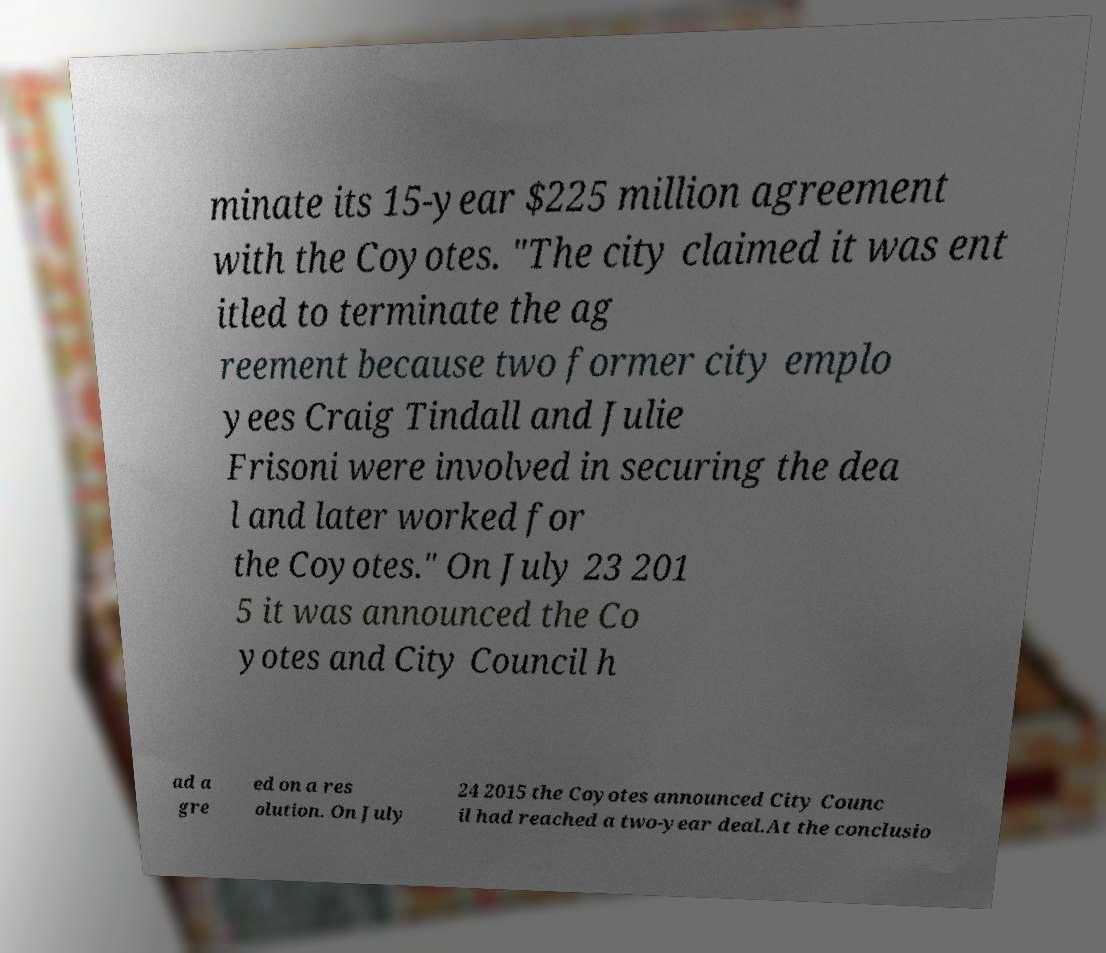Can you read and provide the text displayed in the image?This photo seems to have some interesting text. Can you extract and type it out for me? minate its 15-year $225 million agreement with the Coyotes. "The city claimed it was ent itled to terminate the ag reement because two former city emplo yees Craig Tindall and Julie Frisoni were involved in securing the dea l and later worked for the Coyotes." On July 23 201 5 it was announced the Co yotes and City Council h ad a gre ed on a res olution. On July 24 2015 the Coyotes announced City Counc il had reached a two-year deal.At the conclusio 